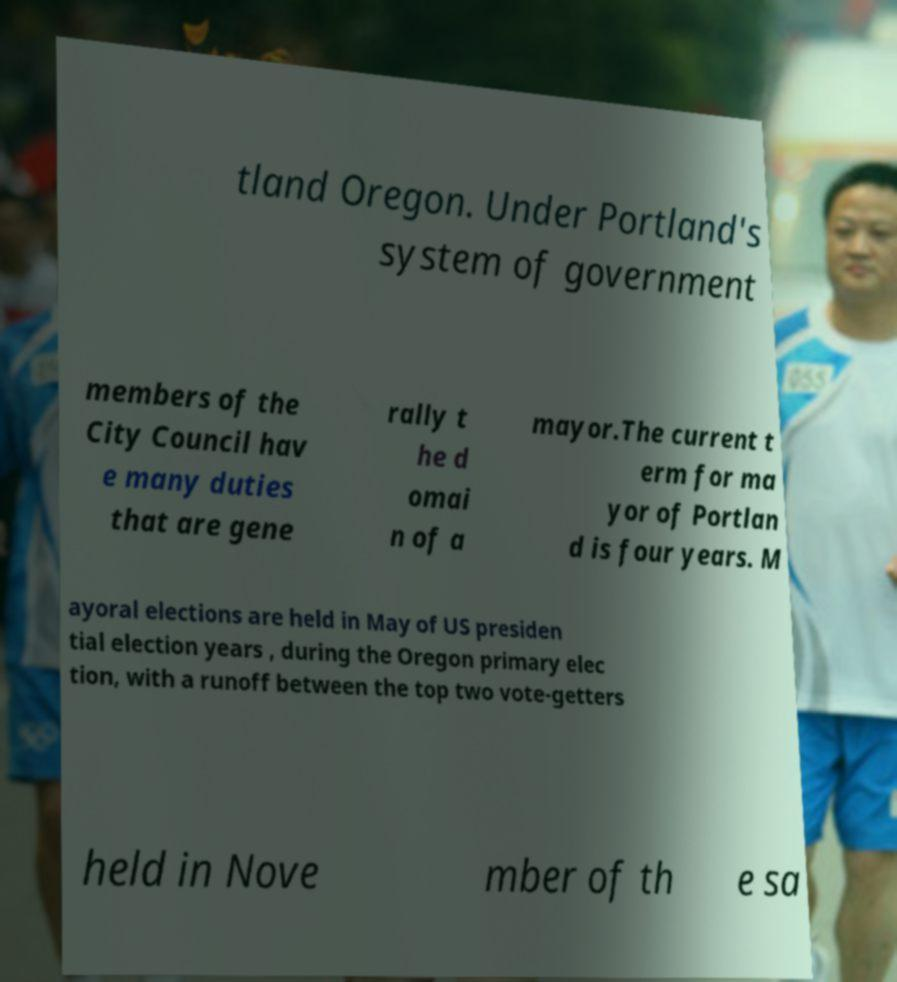Please identify and transcribe the text found in this image. tland Oregon. Under Portland's system of government members of the City Council hav e many duties that are gene rally t he d omai n of a mayor.The current t erm for ma yor of Portlan d is four years. M ayoral elections are held in May of US presiden tial election years , during the Oregon primary elec tion, with a runoff between the top two vote-getters held in Nove mber of th e sa 